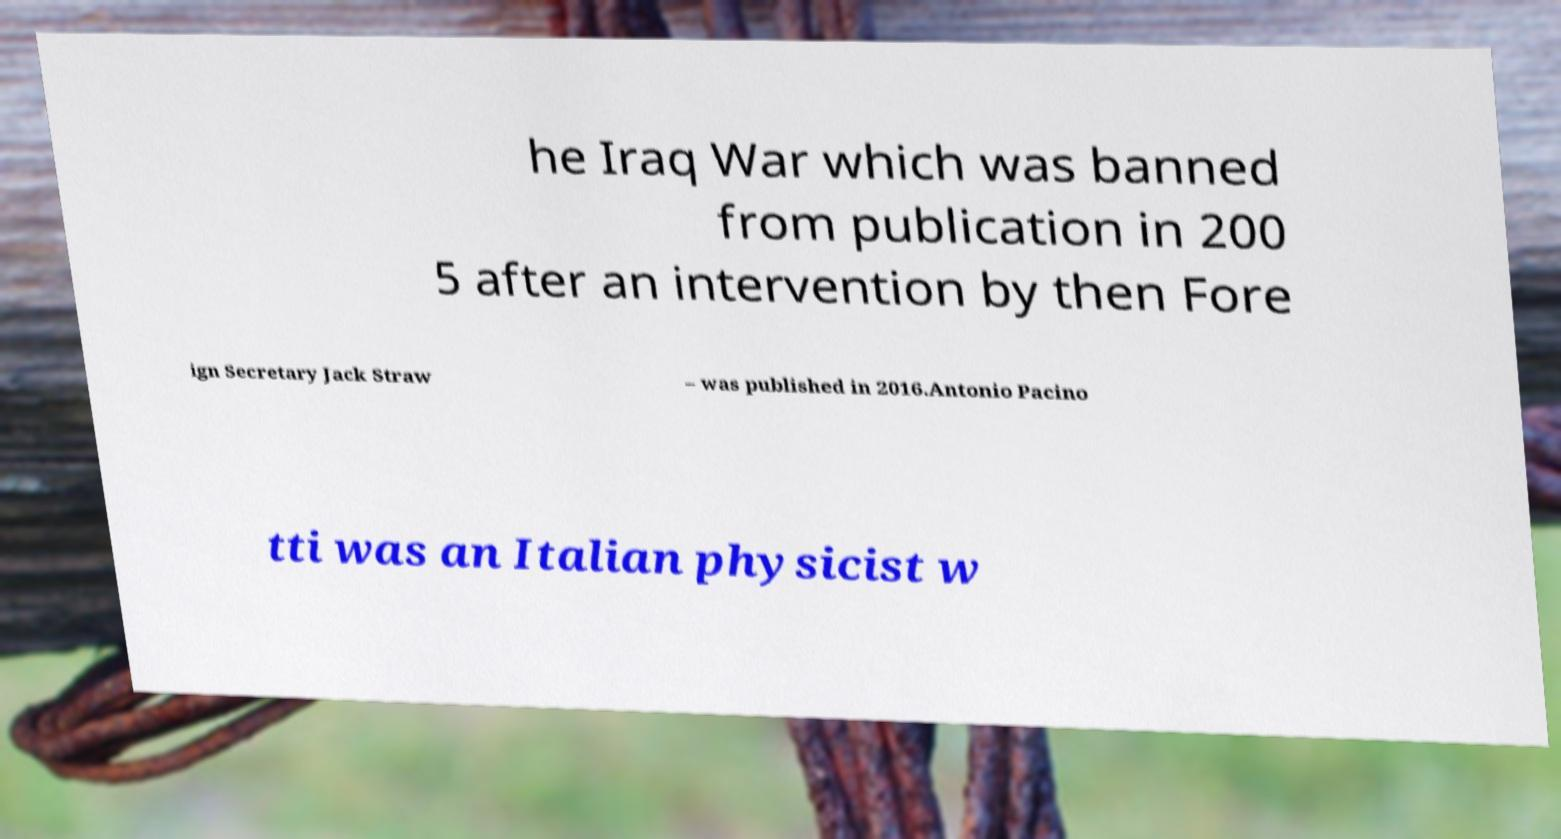Please read and relay the text visible in this image. What does it say? he Iraq War which was banned from publication in 200 5 after an intervention by then Fore ign Secretary Jack Straw – was published in 2016.Antonio Pacino tti was an Italian physicist w 